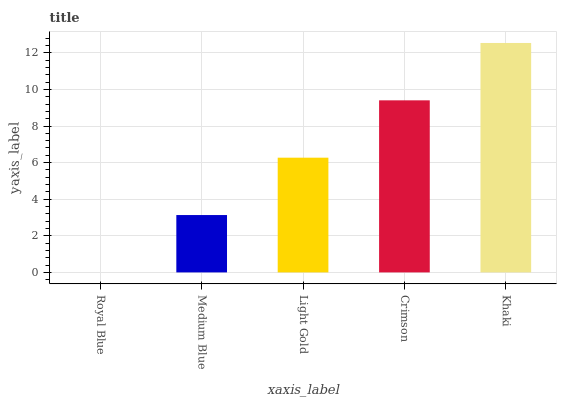Is Royal Blue the minimum?
Answer yes or no. Yes. Is Khaki the maximum?
Answer yes or no. Yes. Is Medium Blue the minimum?
Answer yes or no. No. Is Medium Blue the maximum?
Answer yes or no. No. Is Medium Blue greater than Royal Blue?
Answer yes or no. Yes. Is Royal Blue less than Medium Blue?
Answer yes or no. Yes. Is Royal Blue greater than Medium Blue?
Answer yes or no. No. Is Medium Blue less than Royal Blue?
Answer yes or no. No. Is Light Gold the high median?
Answer yes or no. Yes. Is Light Gold the low median?
Answer yes or no. Yes. Is Medium Blue the high median?
Answer yes or no. No. Is Khaki the low median?
Answer yes or no. No. 